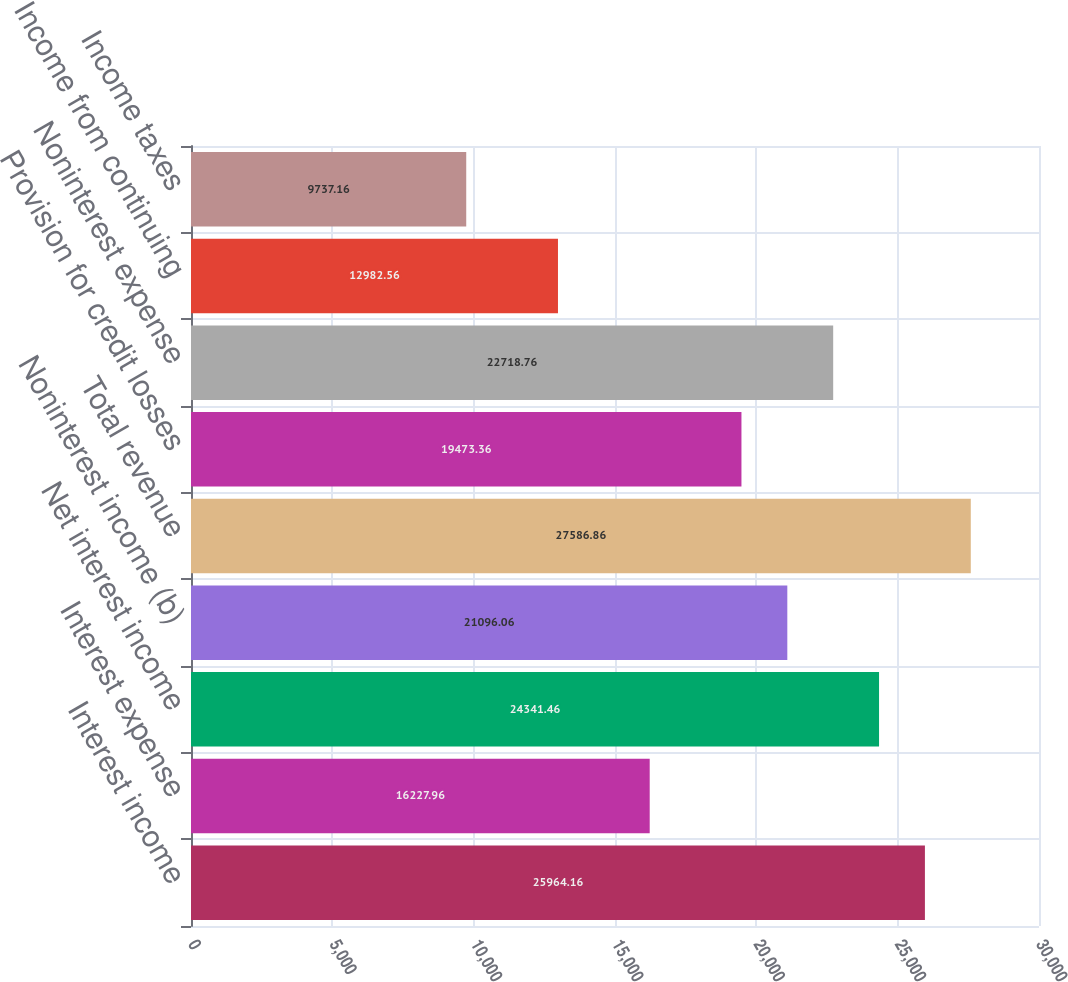Convert chart to OTSL. <chart><loc_0><loc_0><loc_500><loc_500><bar_chart><fcel>Interest income<fcel>Interest expense<fcel>Net interest income<fcel>Noninterest income (b)<fcel>Total revenue<fcel>Provision for credit losses<fcel>Noninterest expense<fcel>Income from continuing<fcel>Income taxes<nl><fcel>25964.2<fcel>16228<fcel>24341.5<fcel>21096.1<fcel>27586.9<fcel>19473.4<fcel>22718.8<fcel>12982.6<fcel>9737.16<nl></chart> 